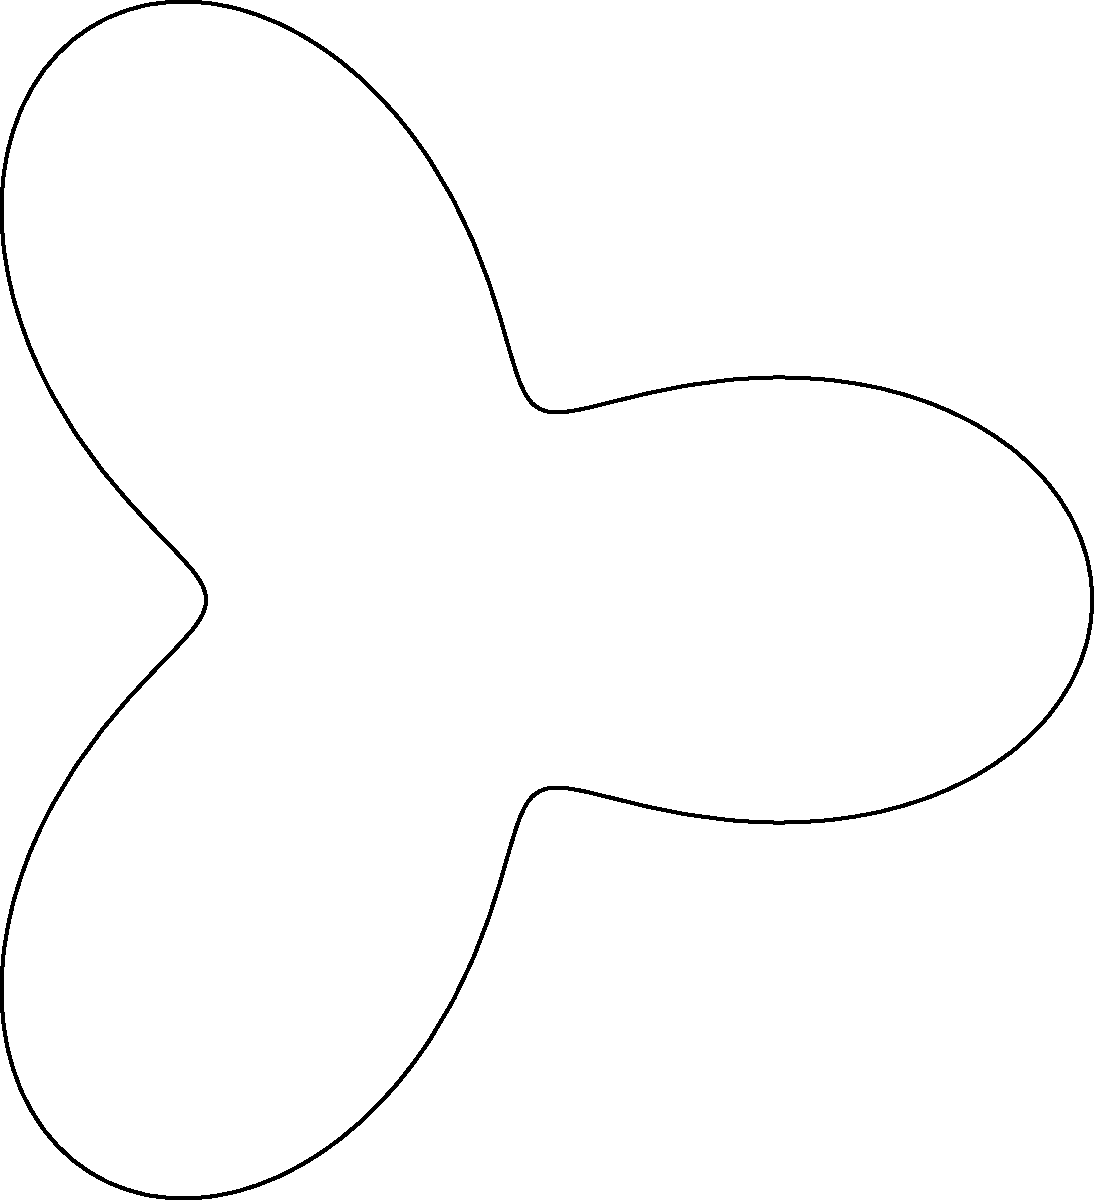In the polar coordinate system shown, which represents the interconnectedness of various mental health issues, what mathematical function best describes the shape of the curve? To determine the mathematical function that best describes the shape of the curve in the polar coordinate system, we need to analyze its characteristics:

1. The curve has a basic circular shape, indicated by the dashed circle with radius 2.
2. The curve has three distinct "lobes" or petals, suggesting a trigonometric function with a period of $\frac{2\pi}{3}$.
3. The curve's radius varies between 1 and 3, as it oscillates around the dashed circle.

Given these observations, we can deduce that the function is of the form:

$$r(\theta) = a + b \cos(n\theta)$$

Where:
- $a$ is the average radius (in this case, 2)
- $b$ is the amplitude of the oscillation (in this case, 1)
- $n$ is the number of petals (in this case, 3)

Therefore, the function that best describes this curve is:

$$r(\theta) = 2 + \cos(3\theta)$$

This function creates a curve that:
- Has an average radius of 2
- Oscillates with an amplitude of 1 around this average
- Completes 3 full oscillations in one revolution (0 to $2\pi$)

The resulting shape accurately represents the interconnectedness of the mental health issues shown in the diagram, with each lobe potentially representing areas of overlap or interaction between different conditions.
Answer: $r(\theta) = 2 + \cos(3\theta)$ 